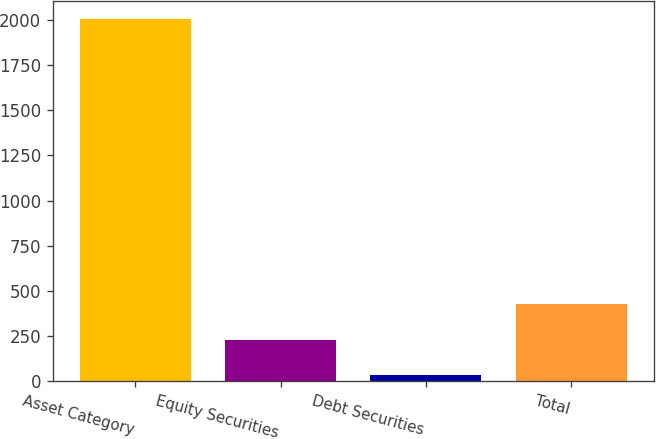Convert chart. <chart><loc_0><loc_0><loc_500><loc_500><bar_chart><fcel>Asset Category<fcel>Equity Securities<fcel>Debt Securities<fcel>Total<nl><fcel>2004<fcel>231<fcel>34<fcel>428<nl></chart> 